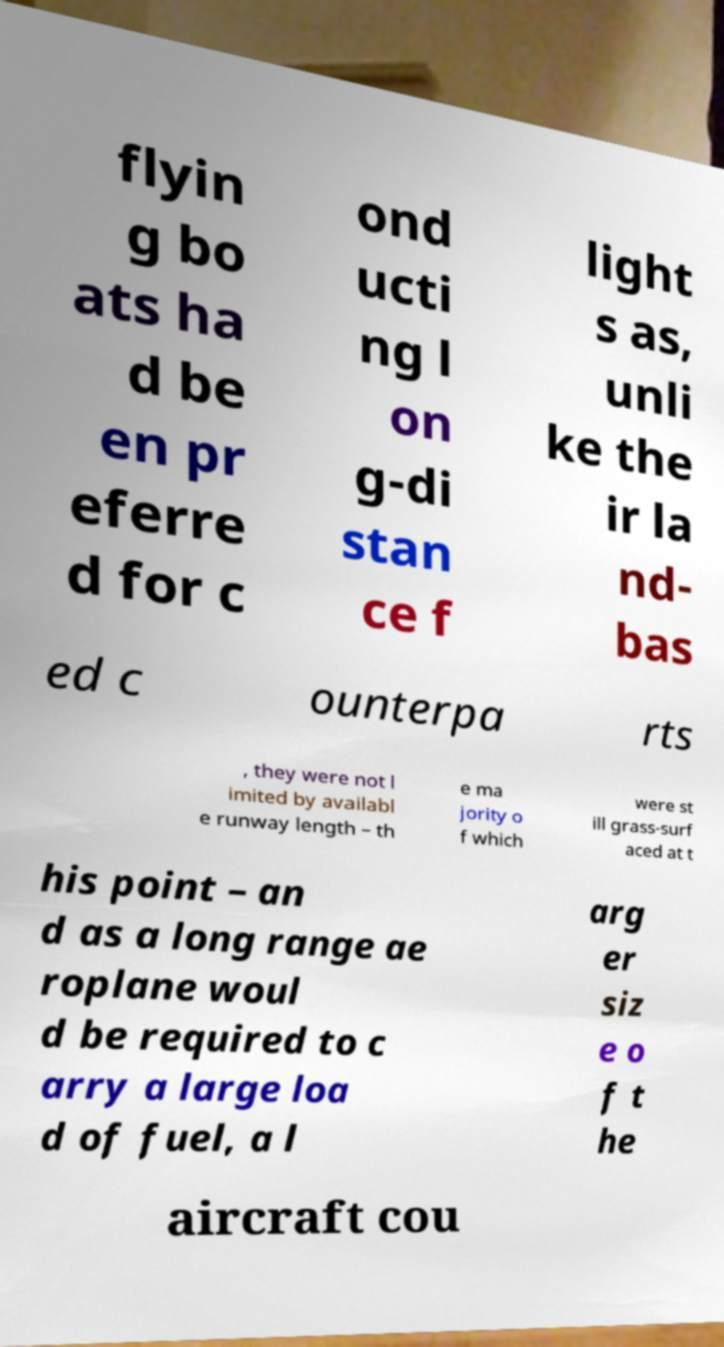What messages or text are displayed in this image? I need them in a readable, typed format. flyin g bo ats ha d be en pr eferre d for c ond ucti ng l on g-di stan ce f light s as, unli ke the ir la nd- bas ed c ounterpa rts , they were not l imited by availabl e runway length – th e ma jority o f which were st ill grass-surf aced at t his point – an d as a long range ae roplane woul d be required to c arry a large loa d of fuel, a l arg er siz e o f t he aircraft cou 